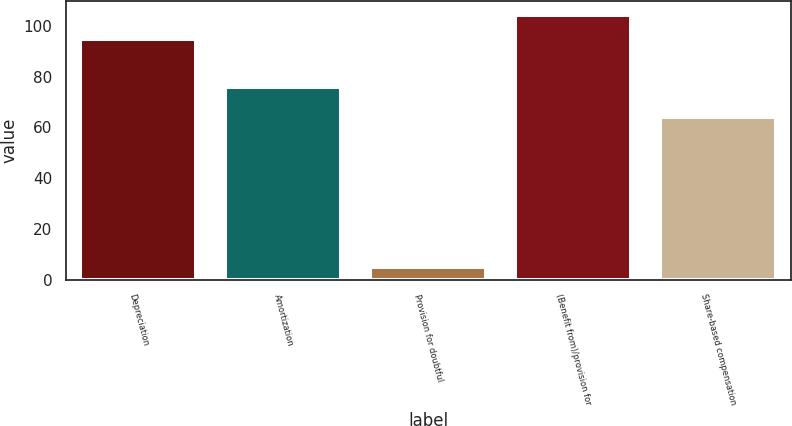Convert chart to OTSL. <chart><loc_0><loc_0><loc_500><loc_500><bar_chart><fcel>Depreciation<fcel>Amortization<fcel>Provision for doubtful<fcel>(Benefit from)/provision for<fcel>Share-based compensation<nl><fcel>95<fcel>76<fcel>5<fcel>104.4<fcel>64<nl></chart> 